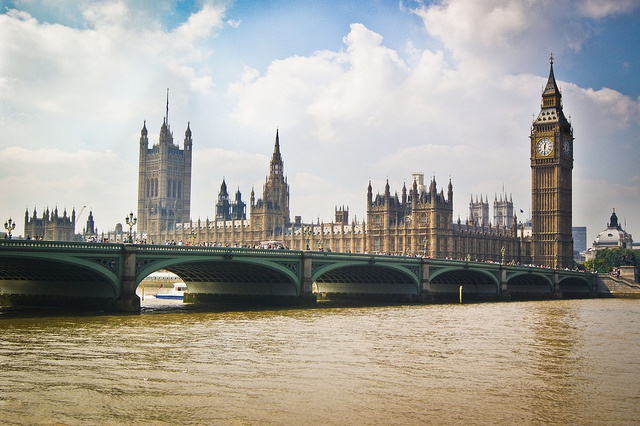Describe the objects in this image and their specific colors. I can see clock in lightblue, darkgray, gray, lightgray, and tan tones and clock in lightblue, gray, black, and darkblue tones in this image. 